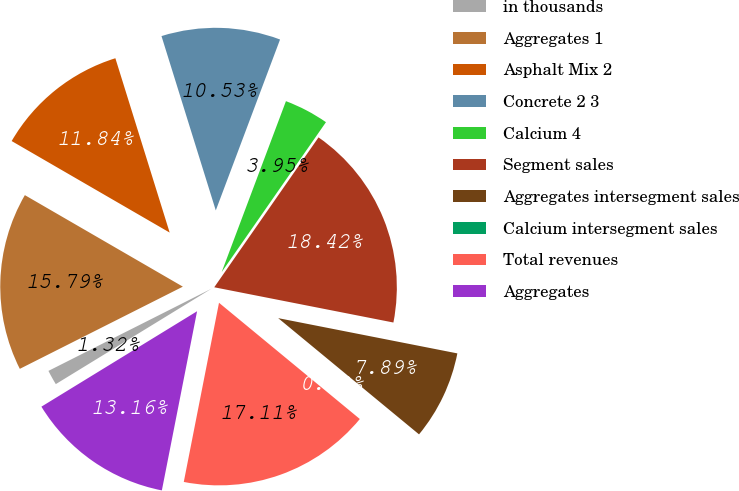<chart> <loc_0><loc_0><loc_500><loc_500><pie_chart><fcel>in thousands<fcel>Aggregates 1<fcel>Asphalt Mix 2<fcel>Concrete 2 3<fcel>Calcium 4<fcel>Segment sales<fcel>Aggregates intersegment sales<fcel>Calcium intersegment sales<fcel>Total revenues<fcel>Aggregates<nl><fcel>1.32%<fcel>15.79%<fcel>11.84%<fcel>10.53%<fcel>3.95%<fcel>18.42%<fcel>7.89%<fcel>0.0%<fcel>17.11%<fcel>13.16%<nl></chart> 